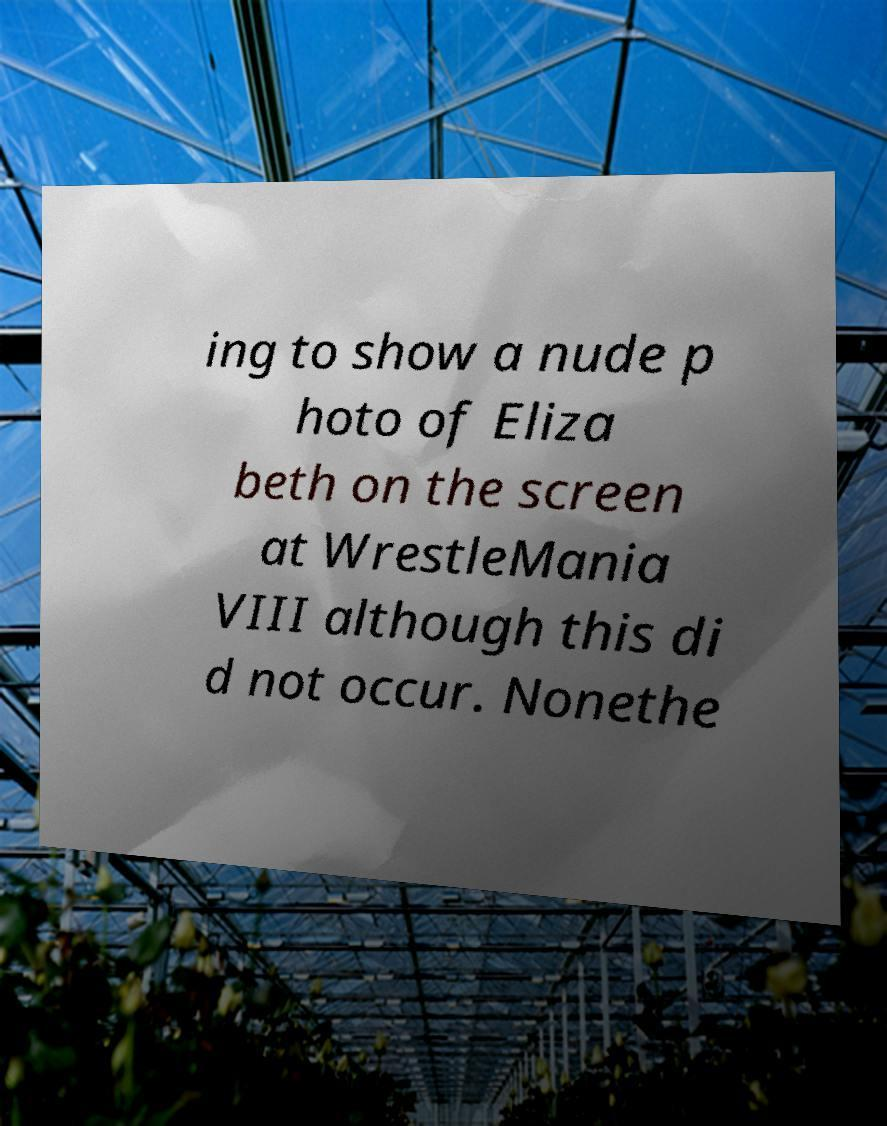Please read and relay the text visible in this image. What does it say? ing to show a nude p hoto of Eliza beth on the screen at WrestleMania VIII although this di d not occur. Nonethe 